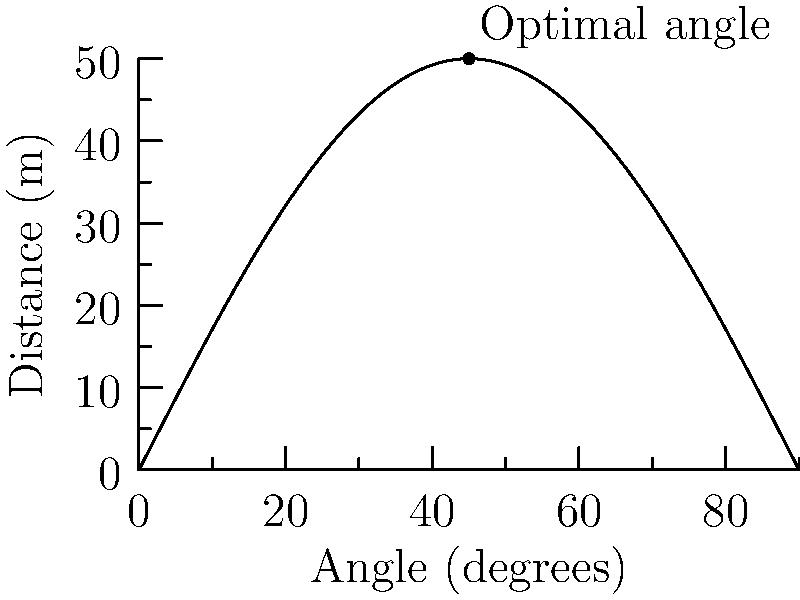As a seasoned football fan, you're reminiscing about the legendary penalty kicks of Oleg Blokhin. You wonder about the optimal angle for a penalty kick to maximize the distance the ball travels. Given that the distance $d$ (in meters) the ball travels is modeled by the function $d(\theta) = 50\sin(2\theta)$, where $\theta$ is the angle of elevation in degrees, what is the optimal angle for maximum distance? Round your answer to the nearest degree. To find the optimal angle, we need to maximize the function $d(\theta) = 50\sin(2\theta)$. Here's how we can do this:

1) The sine function reaches its maximum value of 1 when its argument is 90°.

2) In our case, we want $2\theta$ to equal 90°.

3) Solving for $\theta$:
   $2\theta = 90°$
   $\theta = 45°$

4) We can verify this by looking at the graph, where we see the peak occurs at 45°.

5) This result aligns with physics principles: a 45° angle maximizes the range of a projectile in ideal conditions.

Therefore, the optimal angle for maximum distance is 45°.
Answer: 45° 